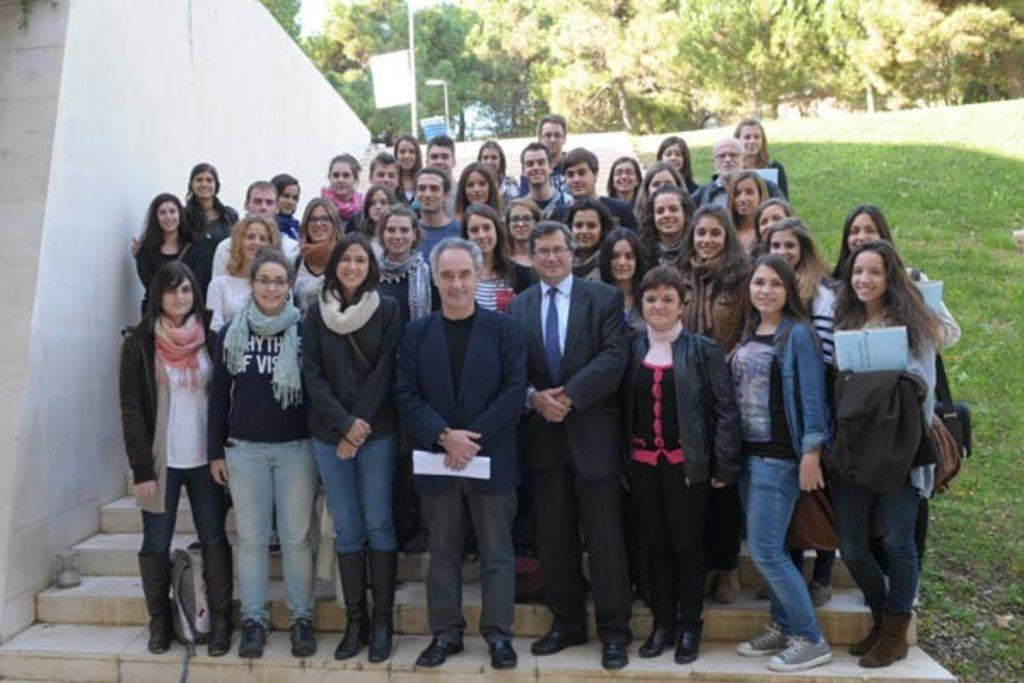How many people are in the image? There is a group of people standing in the image. What is the man holding in the image? The man is holding papers in the image. What type of terrain is visible in the image? There is grass visible in the image. What architectural features can be seen in the image? There are steps and a wall in the image. What can be seen in the background of the image? Trees, boards, and lights on poles are visible in the background of the image. What type of coal is being used to fuel the home in the image? There is no home or coal present in the image. What type of authority figure can be seen in the image? There is no authority figure present in the image. 